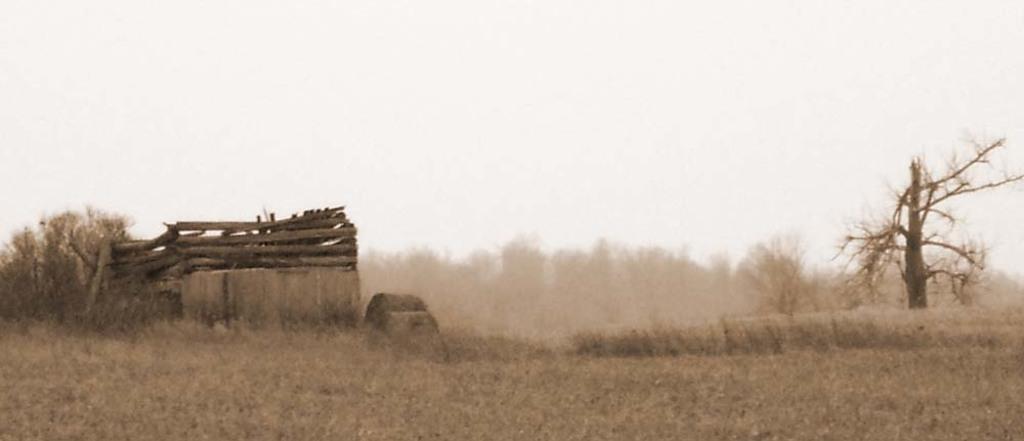Describe this image in one or two sentences. In this picture there is a dry grass field. Behind three wooden rafters and some dry trees. 